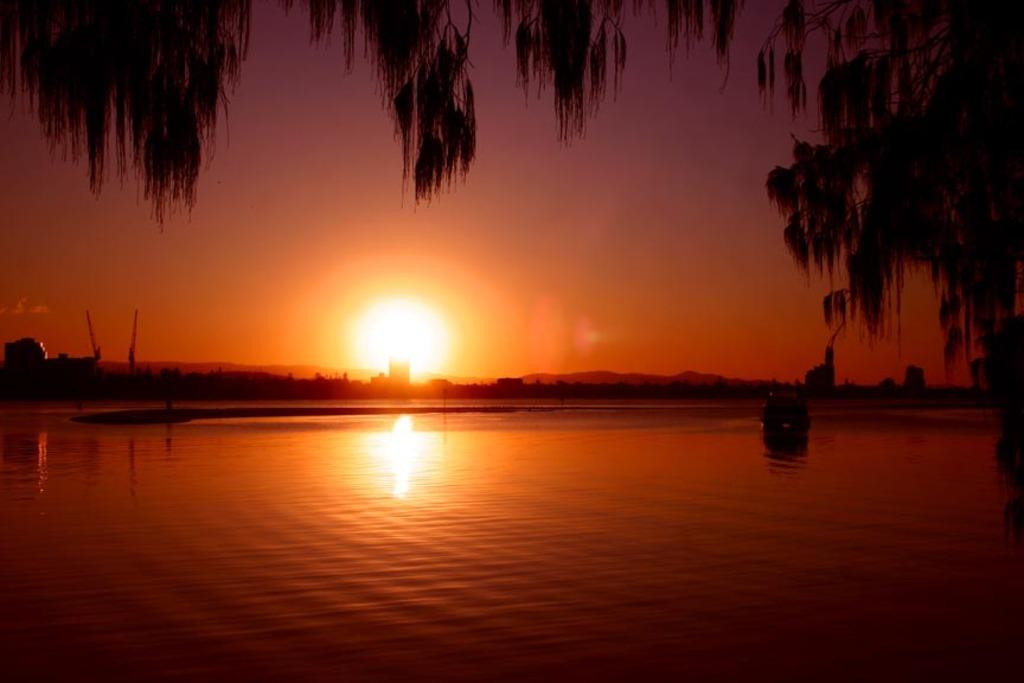What type of vehicles can be seen in the water in the image? There are boats in the water in the image. What type of natural vegetation is present in the image? There are trees in the image. What type of man-made structures can be seen in the image? There are buildings in the image. What type of machinery is present in the image? There are cranes in the image. What type of geological feature is present in the image? There are mountains in the image. What is visible in the sky at the top of the image? The sun is visible in the sky at the top of the image. Where are the books located in the image? There are no books present in the image. What type of tool is being used by the boats in the image? Boats do not use tools like wrenches; they are powered by engines or sails. 